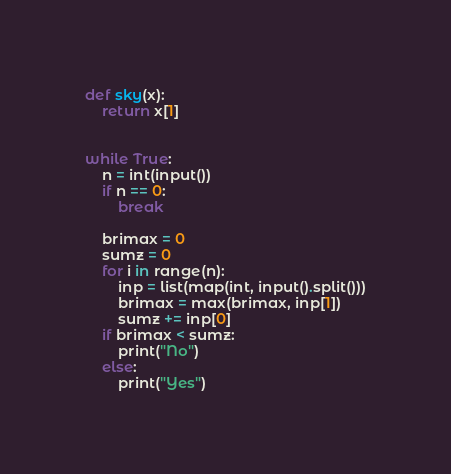Convert code to text. <code><loc_0><loc_0><loc_500><loc_500><_Python_>def sky(x):
    return x[1]


while True:
    n = int(input())
    if n == 0:
        break
    
    brimax = 0
    sumz = 0
    for i in range(n):
        inp = list(map(int, input().split()))
        brimax = max(brimax, inp[1])
        sumz += inp[0]
    if brimax < sumz:
        print("No")
    else:
        print("Yes")

</code> 